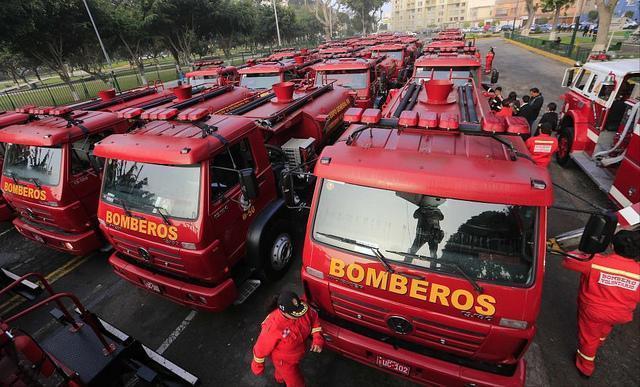How many trucks are in the picture?
Give a very brief answer. 5. How many people can be seen?
Give a very brief answer. 2. How many dogs are sleeping in the image ?
Give a very brief answer. 0. 